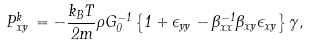Convert formula to latex. <formula><loc_0><loc_0><loc_500><loc_500>\, P _ { x y } ^ { k } \, = - \frac { k _ { B } T } { 2 m } \rho G ^ { - 1 } _ { 0 } \left \{ 1 + \epsilon _ { y y } - \beta _ { x x } ^ { - 1 } \beta _ { x y } \epsilon _ { x y } \right \} \gamma ,</formula> 